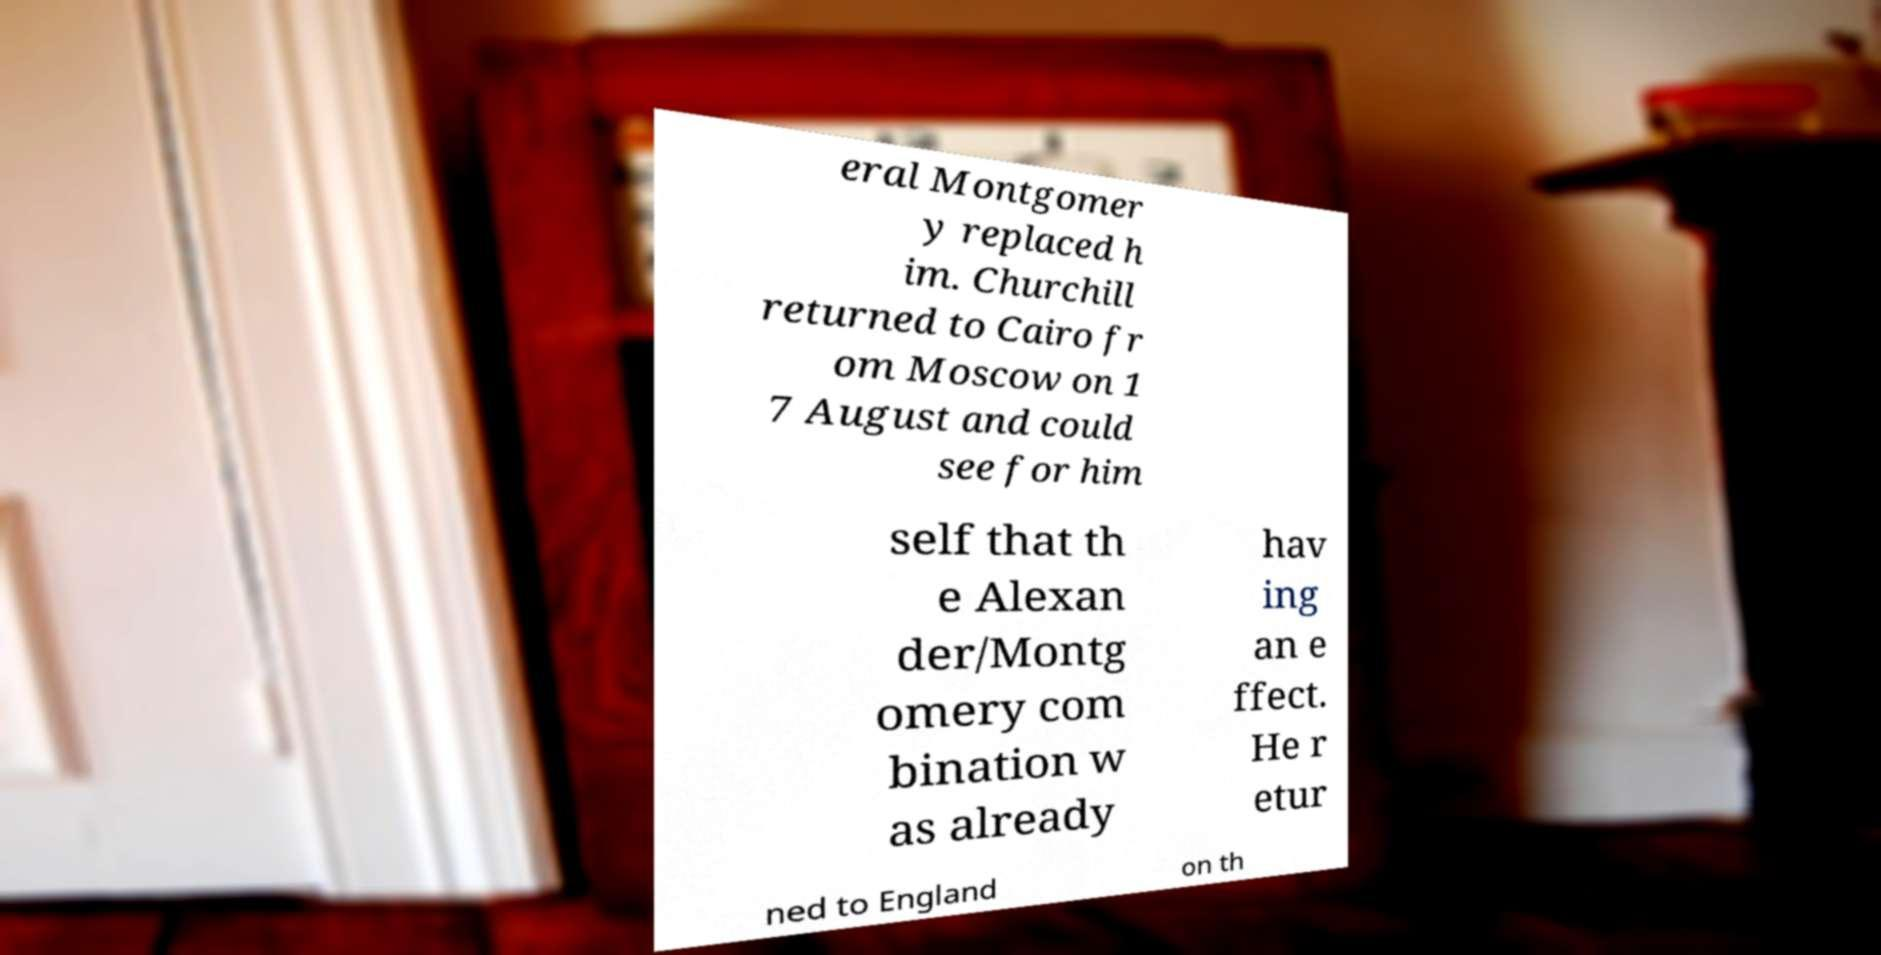Could you assist in decoding the text presented in this image and type it out clearly? eral Montgomer y replaced h im. Churchill returned to Cairo fr om Moscow on 1 7 August and could see for him self that th e Alexan der/Montg omery com bination w as already hav ing an e ffect. He r etur ned to England on th 